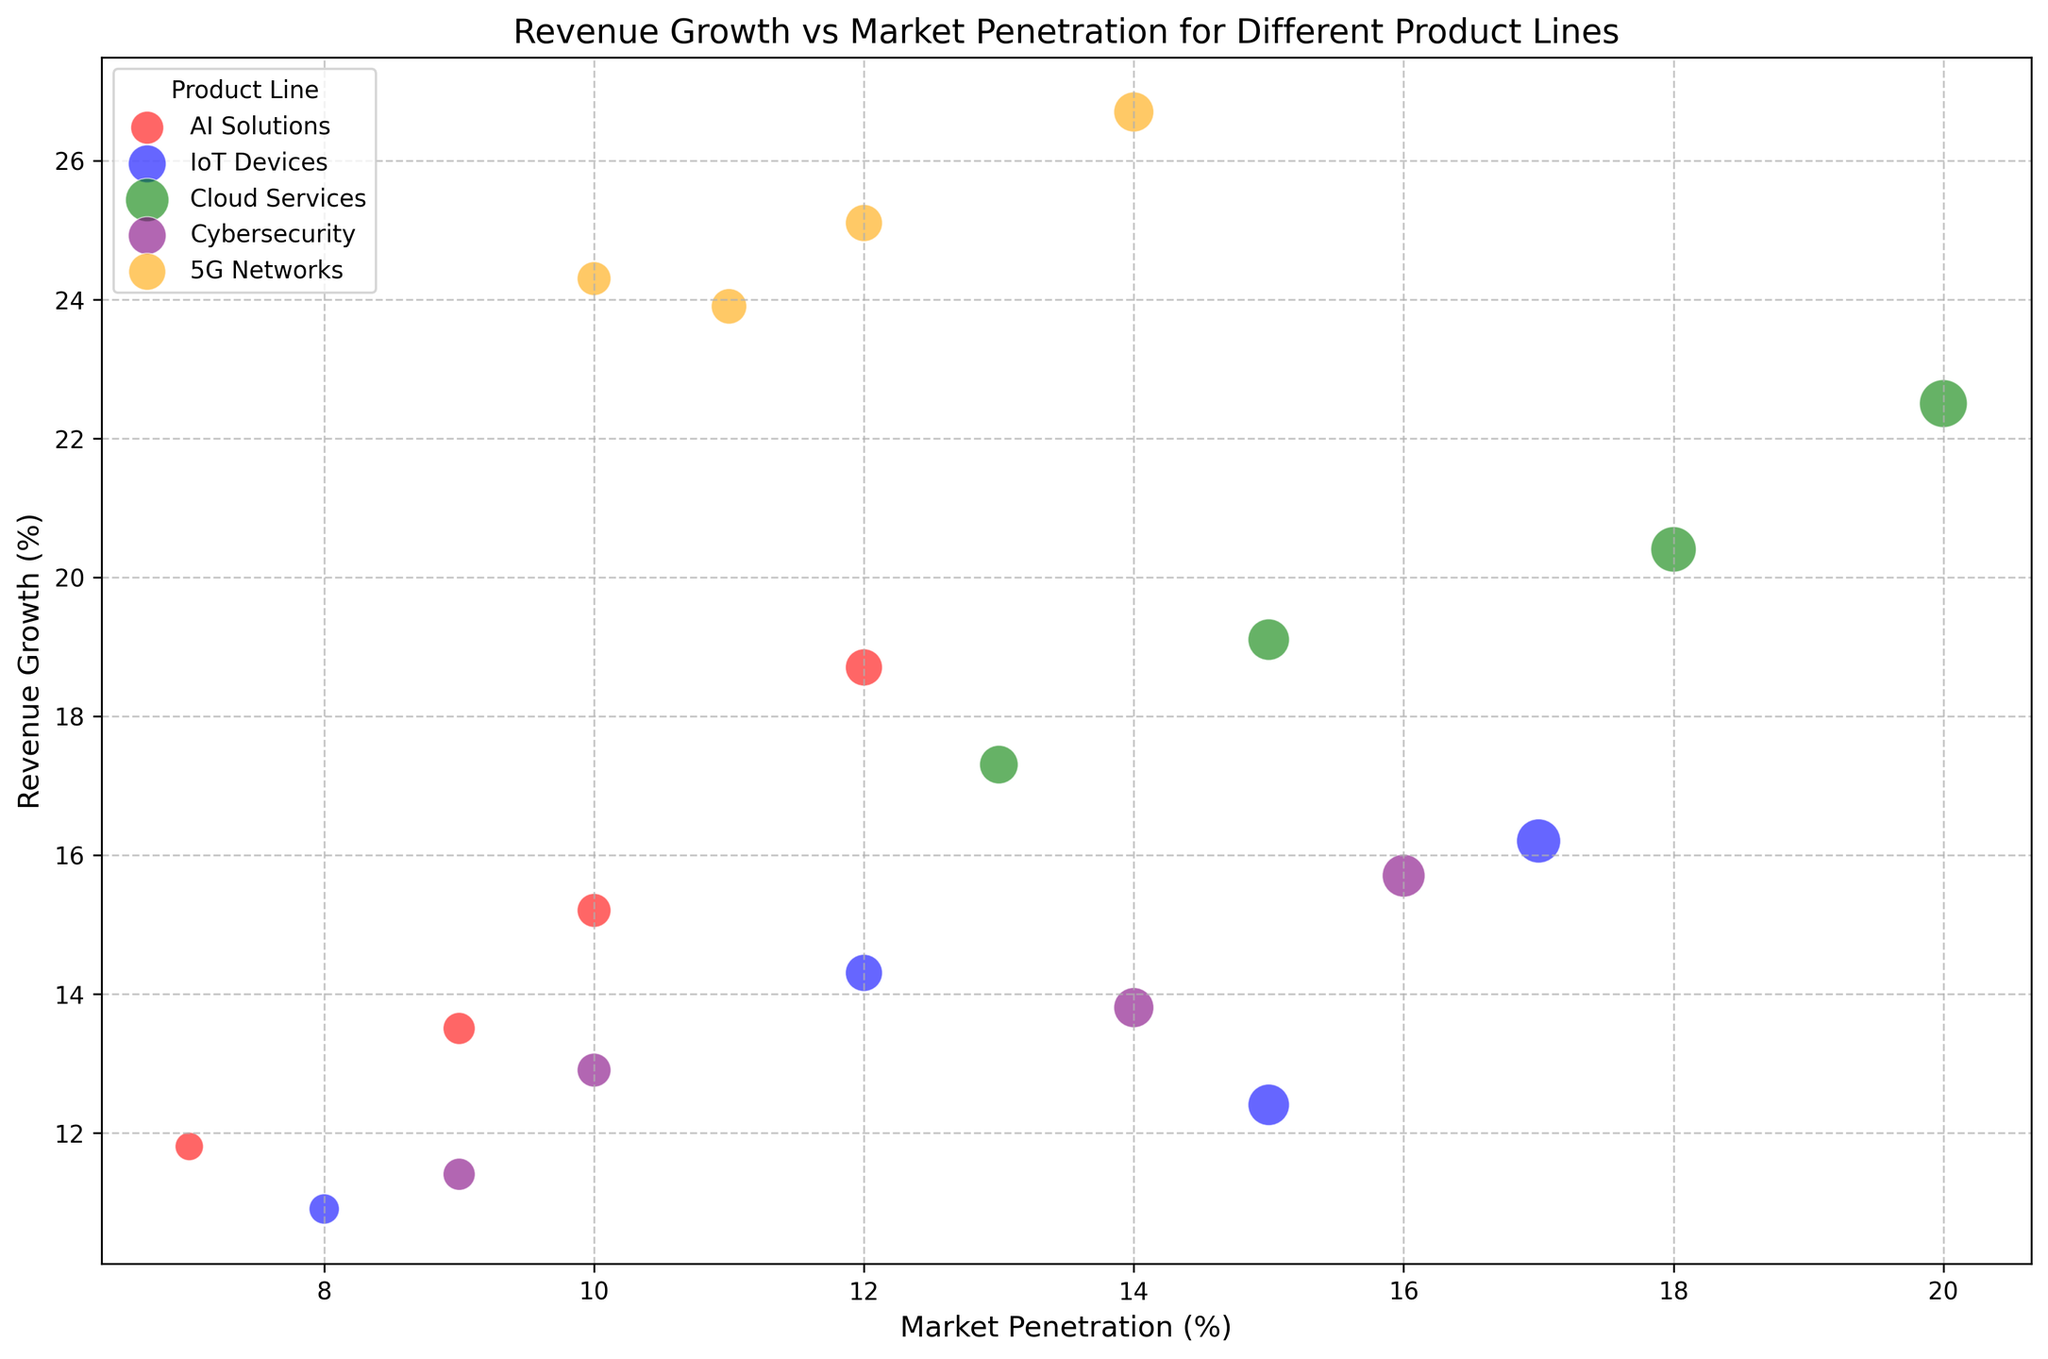What is the region with the highest revenue growth for 5G Networks? To determine the region with the highest revenue growth for 5G Networks, look for the 5G Networks bubbles and compare their vertical positions. The highest bubble represents the highest revenue growth. The 5G Networks bubble with the highest revenue growth is in Asia.
Answer: Asia Which product line has the highest revenue growth overall? To find the product line with the highest revenue growth overall, identify the highest bubble across all product lines. The highest point on the graph corresponds to Cloud Services in Asia with 22.5%.
Answer: Cloud Services What is the difference in market penetration between Cybersecurity in North America and South America? To find this, locate the Cybersecurity bubbles for North America and South America. Note their horizontal positions and subtract the smaller value from the larger one. North America has 14% market penetration, and South America has 9%, so the difference is 14% - 9% = 5%.
Answer: 5% Which product line in North America has the lowest revenue growth? Compare the vertical positions of the bubbles representing different product lines in North America. The lowest bubble corresponds to IoT Devices with 12.4%.
Answer: IoT Devices Is the market penetration of AI Solutions in Asia higher or lower than Cloud Services in Europe? To determine this, compare the horizontal positions of the bubbles for AI Solutions in Asia and Cloud Services in Europe. AI Solutions in Asia is at 12%, while Cloud Services in Europe is at 15%. Since 12% < 15%, it is lower.
Answer: Lower Which region shows higher revenue growth for AI Solutions, Europe or South America? Compare the vertical positions of the AI Solutions bubbles in Europe and South America. Europe is at 13.5%, while South America is at 11.8%. Therefore, Europe has higher revenue growth.
Answer: Europe What is the average revenue growth of IoT Devices across all regions? To calculate the average revenue growth of IoT Devices across all regions, sum the revenue growth values for IoT Devices and divide by the number of regions. The values are 12.4, 14.3, 16.2, and 10.9. Their sum is 53.8, and dividing by 4 yields 53.8 / 4 = approximately 13.45%.
Answer: ~13.45% Does Cybersecurity in Asia have higher or lower market penetration compared to AI Solutions in North America? Compare the horizontal positions of the Cybersecurity bubble in Asia and the AI Solutions bubble in North America. Cybersecurity in Asia has 16%, and AI Solutions in North America has 10%. Since 16% > 10%, it is higher.
Answer: Higher Which product line has a larger bubble size in Europe, IoT Devices or Cybersecurity? Bubble size is proportional to market penetration. Compare the sizes of the IoT Devices and Cybersecurity bubbles in Europe. IoT Devices in Europe is at 12%, whereas Cybersecurity is at 10%. Thus, IoT Devices has a larger bubble size.
Answer: IoT Devices 